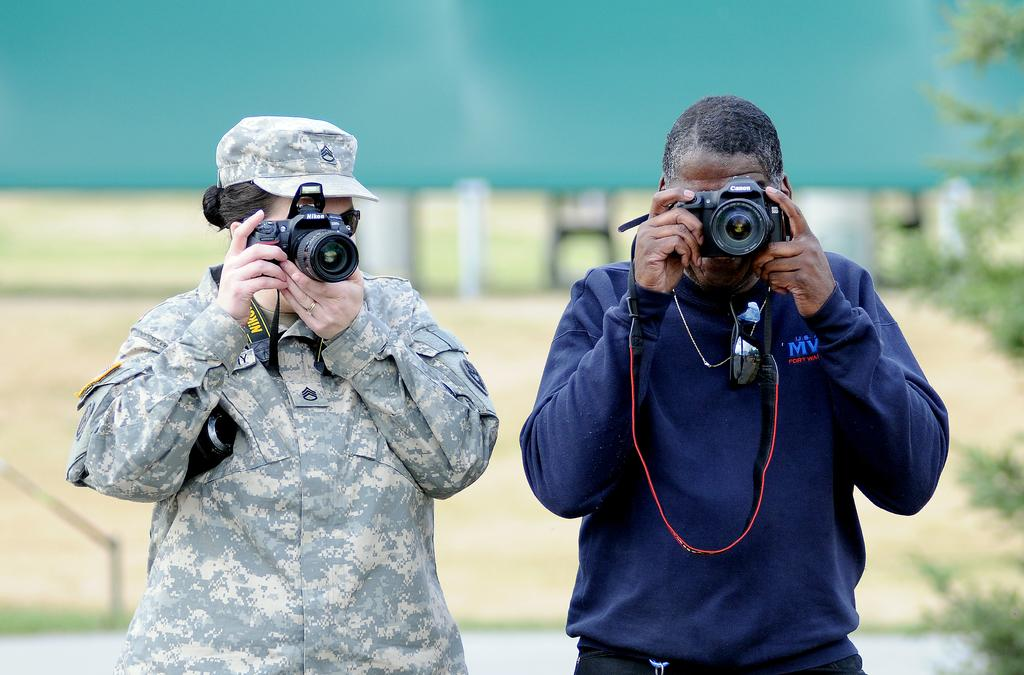How many people are the number of people in the image? There are two persons in the image. What are the persons holding in the image? Both persons are holding cameras. Can you describe the clothing of one of the persons? One person is wearing a cap. What can be seen in the background of the image? There are plants and grass in the background of the image. What type of sheet is covering the sky in the image? There is no sheet covering the sky in the image; the sky is visible in the background. How does the pain affect the persons in the image? There is no mention of pain or any negative emotions in the image; both persons are holding cameras and appear to be engaged in a positive activity. 